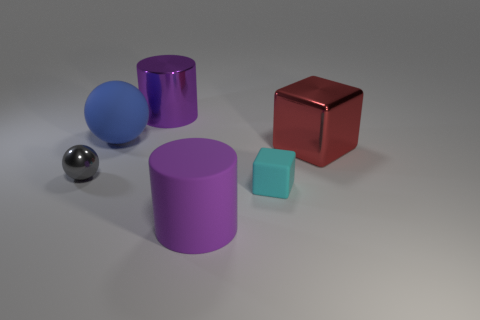Add 3 blue matte balls. How many objects exist? 9 Subtract all spheres. How many objects are left? 4 Add 1 small cyan metal cubes. How many small cyan metal cubes exist? 1 Subtract 1 blue spheres. How many objects are left? 5 Subtract all small brown rubber balls. Subtract all large shiny things. How many objects are left? 4 Add 1 blue rubber things. How many blue rubber things are left? 2 